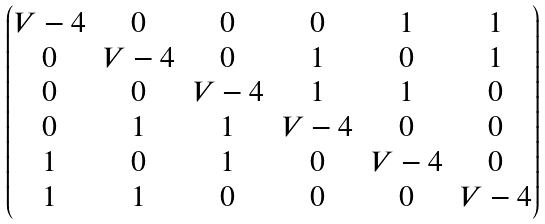<formula> <loc_0><loc_0><loc_500><loc_500>\begin{pmatrix} V - 4 & 0 & 0 & 0 & 1 & 1 \\ 0 & V - 4 & 0 & 1 & 0 & 1 \\ 0 & 0 & V - 4 & 1 & 1 & 0 \\ 0 & 1 & 1 & V - 4 & 0 & 0 \\ 1 & 0 & 1 & 0 & V - 4 & 0 \\ 1 & 1 & 0 & 0 & 0 & V - 4 \end{pmatrix}</formula> 